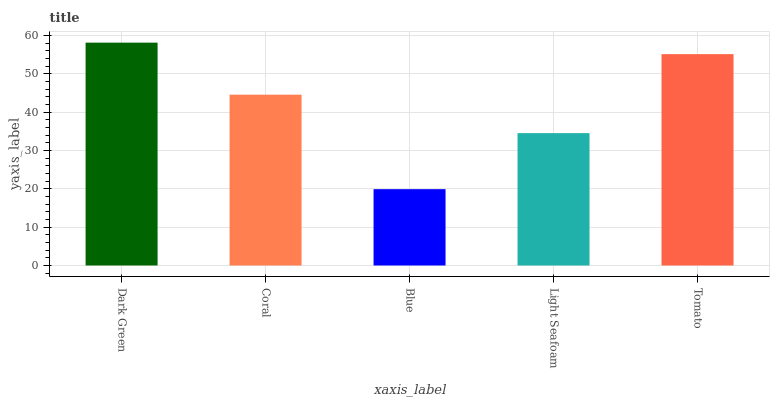Is Blue the minimum?
Answer yes or no. Yes. Is Dark Green the maximum?
Answer yes or no. Yes. Is Coral the minimum?
Answer yes or no. No. Is Coral the maximum?
Answer yes or no. No. Is Dark Green greater than Coral?
Answer yes or no. Yes. Is Coral less than Dark Green?
Answer yes or no. Yes. Is Coral greater than Dark Green?
Answer yes or no. No. Is Dark Green less than Coral?
Answer yes or no. No. Is Coral the high median?
Answer yes or no. Yes. Is Coral the low median?
Answer yes or no. Yes. Is Dark Green the high median?
Answer yes or no. No. Is Tomato the low median?
Answer yes or no. No. 